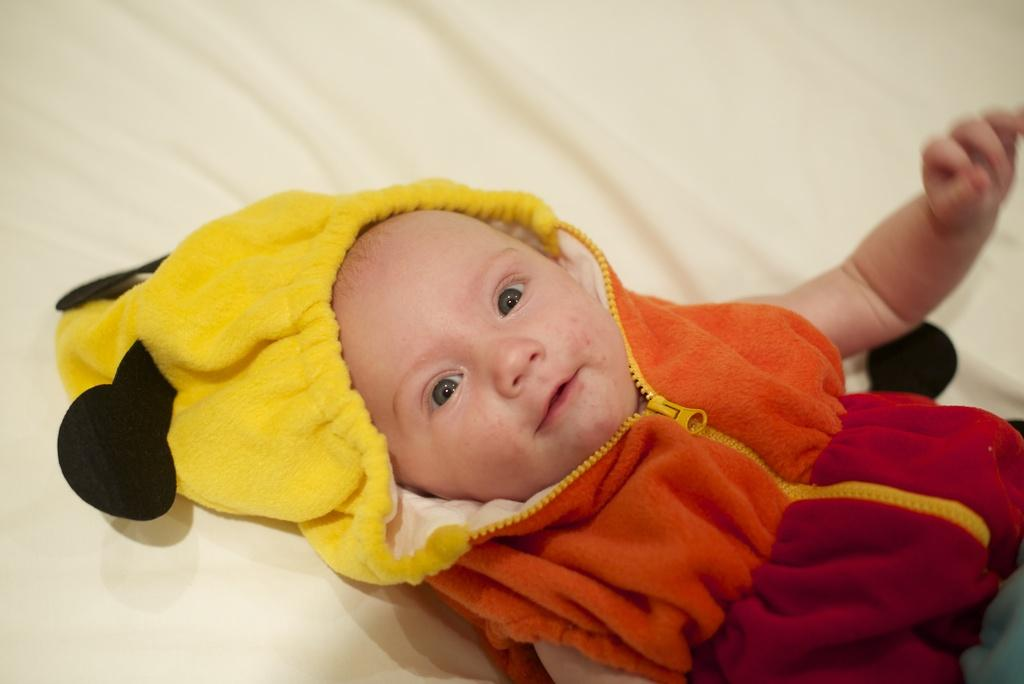What is the main subject of the image? There is a baby in the image. Where is the baby located? The baby is laying on a bed. What is the baby wearing? The baby is wearing a hoodie with yellow, black, red, and orange colors. What color is the background of the image? The background of the image is white. What type of fiction is the baby reading in the image? There is no book or any form of fiction present in the image. What kind of meat is the baby holding in the image? There is no meat or any food item present in the image. 